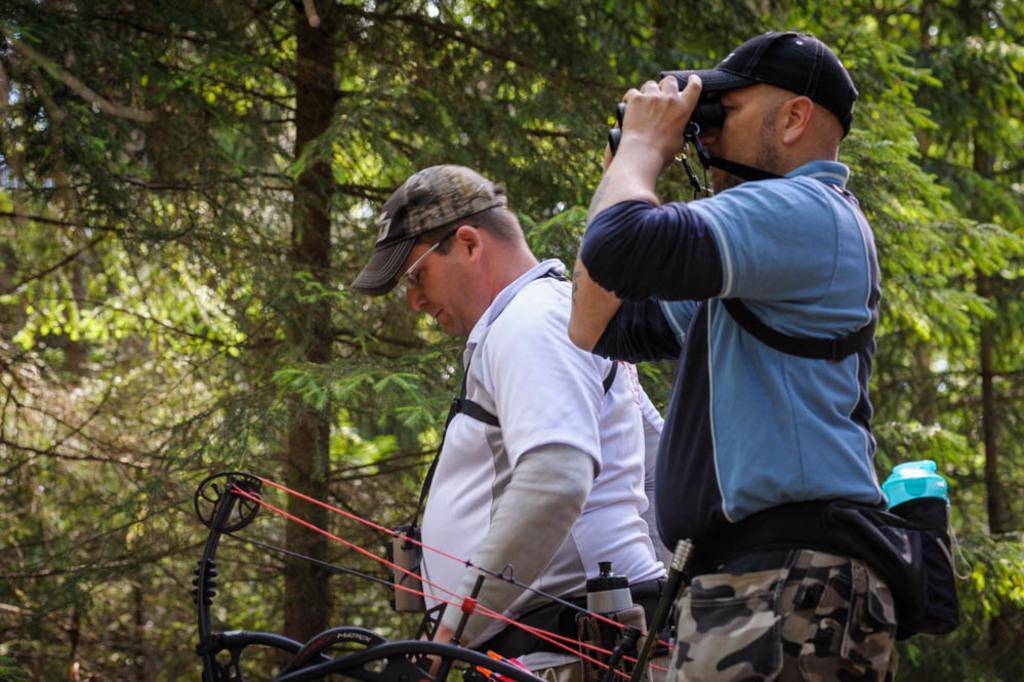How would you summarize this image in a sentence or two? In this picture we can see there are two people standing and a person is holding a binoculars. In front of the people there is an object and behind the people there are trees. 